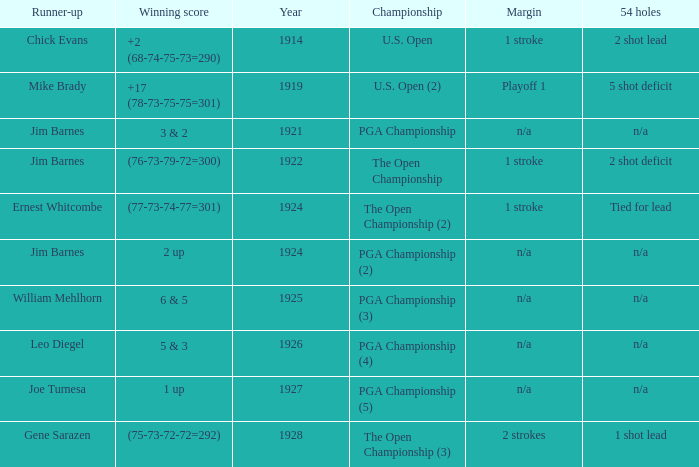HOW MANY YEARS WAS IT FOR THE SCORE (76-73-79-72=300)? 1.0. 